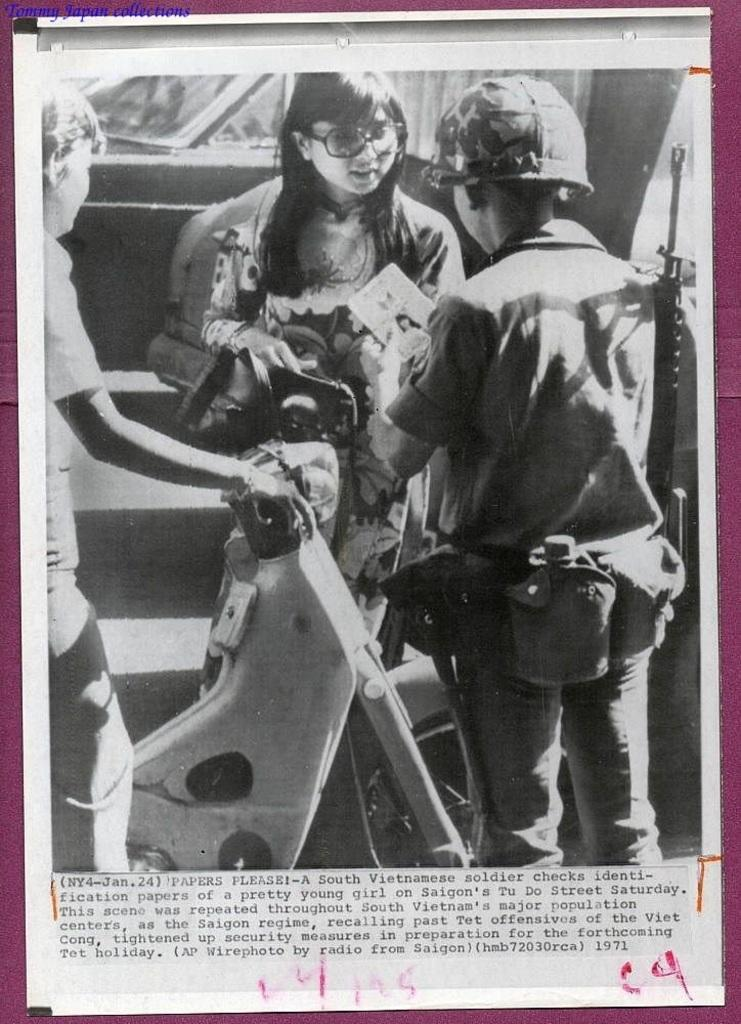What type of content is featured in the image? The image is a newspaper column. How many people are depicted in the image? There are three people in the image. What mode of transportation is present in the image? There is a bike in the image, and there are also vehicles present. Is there any text in the image? Yes, there is text at the bottom of the image. What type of blade is being used by the kitten in the image? There is no kitten or blade present in the image. Where is the office located in the image? There is no office present in the image. 